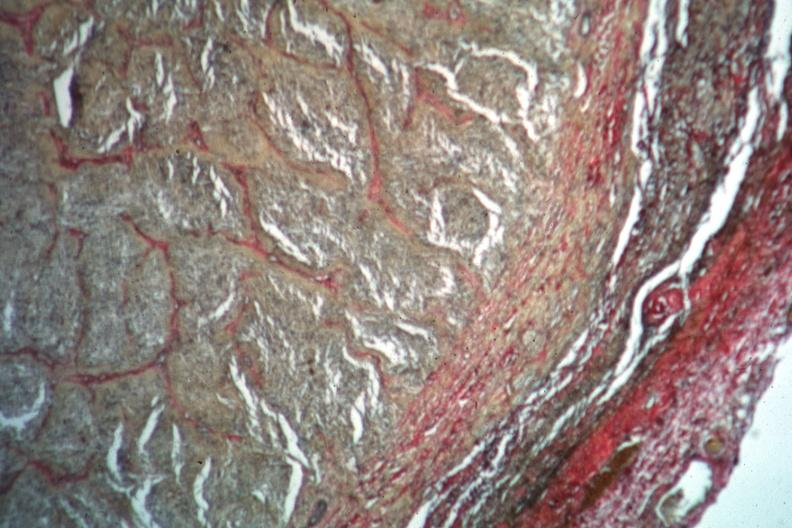what is present?
Answer the question using a single word or phrase. Eye 